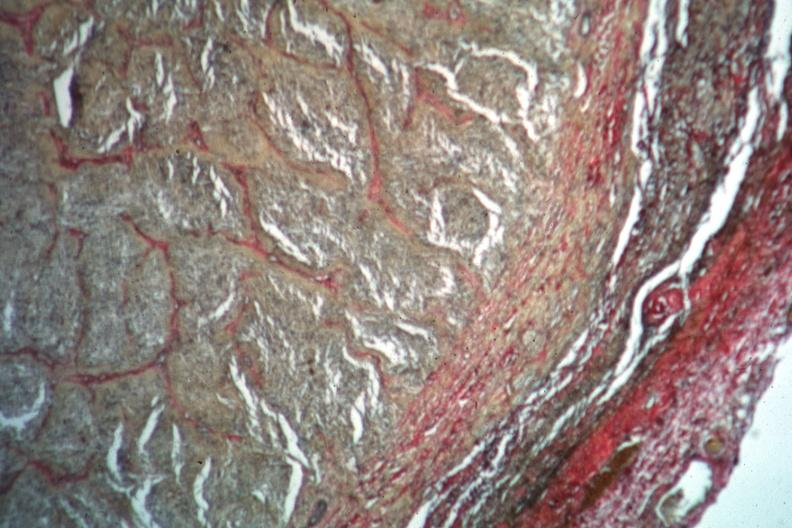what is present?
Answer the question using a single word or phrase. Eye 